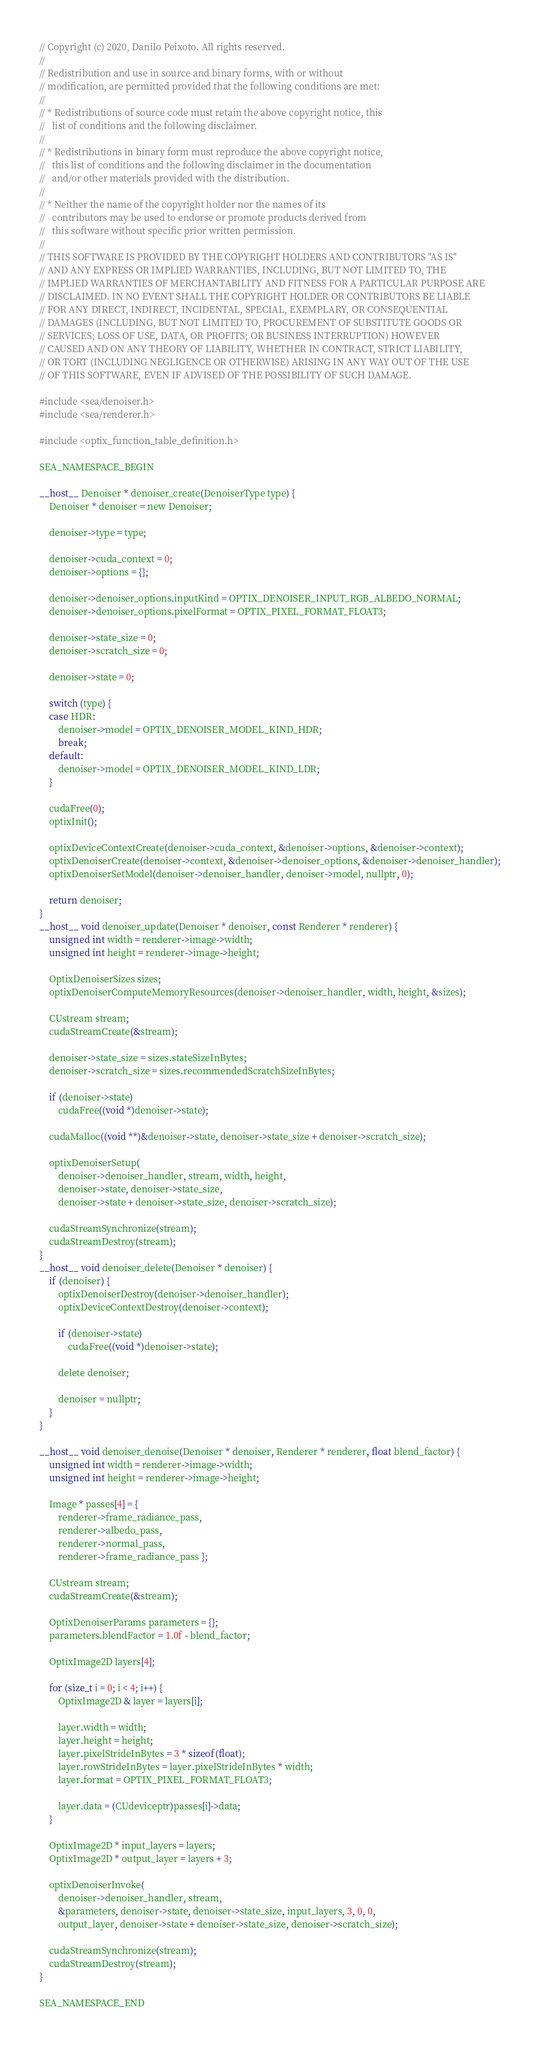Convert code to text. <code><loc_0><loc_0><loc_500><loc_500><_Cuda_>// Copyright (c) 2020, Danilo Peixoto. All rights reserved.
//
// Redistribution and use in source and binary forms, with or without
// modification, are permitted provided that the following conditions are met:
//
// * Redistributions of source code must retain the above copyright notice, this
//   list of conditions and the following disclaimer.
//
// * Redistributions in binary form must reproduce the above copyright notice,
//   this list of conditions and the following disclaimer in the documentation
//   and/or other materials provided with the distribution.
//
// * Neither the name of the copyright holder nor the names of its
//   contributors may be used to endorse or promote products derived from
//   this software without specific prior written permission.
//
// THIS SOFTWARE IS PROVIDED BY THE COPYRIGHT HOLDERS AND CONTRIBUTORS "AS IS"
// AND ANY EXPRESS OR IMPLIED WARRANTIES, INCLUDING, BUT NOT LIMITED TO, THE
// IMPLIED WARRANTIES OF MERCHANTABILITY AND FITNESS FOR A PARTICULAR PURPOSE ARE
// DISCLAIMED. IN NO EVENT SHALL THE COPYRIGHT HOLDER OR CONTRIBUTORS BE LIABLE
// FOR ANY DIRECT, INDIRECT, INCIDENTAL, SPECIAL, EXEMPLARY, OR CONSEQUENTIAL
// DAMAGES (INCLUDING, BUT NOT LIMITED TO, PROCUREMENT OF SUBSTITUTE GOODS OR
// SERVICES; LOSS OF USE, DATA, OR PROFITS; OR BUSINESS INTERRUPTION) HOWEVER
// CAUSED AND ON ANY THEORY OF LIABILITY, WHETHER IN CONTRACT, STRICT LIABILITY,
// OR TORT (INCLUDING NEGLIGENCE OR OTHERWISE) ARISING IN ANY WAY OUT OF THE USE
// OF THIS SOFTWARE, EVEN IF ADVISED OF THE POSSIBILITY OF SUCH DAMAGE.

#include <sea/denoiser.h>
#include <sea/renderer.h>

#include <optix_function_table_definition.h>

SEA_NAMESPACE_BEGIN

__host__ Denoiser * denoiser_create(DenoiserType type) {
	Denoiser * denoiser = new Denoiser;

	denoiser->type = type;

	denoiser->cuda_context = 0;
	denoiser->options = {};

	denoiser->denoiser_options.inputKind = OPTIX_DENOISER_INPUT_RGB_ALBEDO_NORMAL;
	denoiser->denoiser_options.pixelFormat = OPTIX_PIXEL_FORMAT_FLOAT3;

	denoiser->state_size = 0;
	denoiser->scratch_size = 0;

	denoiser->state = 0;

	switch (type) {
	case HDR:
		denoiser->model = OPTIX_DENOISER_MODEL_KIND_HDR;
		break;
	default:
		denoiser->model = OPTIX_DENOISER_MODEL_KIND_LDR;
	}

	cudaFree(0);
	optixInit();

	optixDeviceContextCreate(denoiser->cuda_context, &denoiser->options, &denoiser->context);
	optixDenoiserCreate(denoiser->context, &denoiser->denoiser_options, &denoiser->denoiser_handler);
	optixDenoiserSetModel(denoiser->denoiser_handler, denoiser->model, nullptr, 0);

	return denoiser;
}
__host__ void denoiser_update(Denoiser * denoiser, const Renderer * renderer) {
	unsigned int width = renderer->image->width;
	unsigned int height = renderer->image->height;

	OptixDenoiserSizes sizes;
	optixDenoiserComputeMemoryResources(denoiser->denoiser_handler, width, height, &sizes);

	CUstream stream;
	cudaStreamCreate(&stream);

	denoiser->state_size = sizes.stateSizeInBytes;
	denoiser->scratch_size = sizes.recommendedScratchSizeInBytes;

	if (denoiser->state)
		cudaFree((void *)denoiser->state);

	cudaMalloc((void **)&denoiser->state, denoiser->state_size + denoiser->scratch_size);

	optixDenoiserSetup(
		denoiser->denoiser_handler, stream, width, height,
		denoiser->state, denoiser->state_size,
		denoiser->state + denoiser->state_size, denoiser->scratch_size);

	cudaStreamSynchronize(stream);
	cudaStreamDestroy(stream);
}
__host__ void denoiser_delete(Denoiser * denoiser) {
	if (denoiser) {
		optixDenoiserDestroy(denoiser->denoiser_handler);
		optixDeviceContextDestroy(denoiser->context);

		if (denoiser->state)
			cudaFree((void *)denoiser->state);

		delete denoiser;

		denoiser = nullptr;
	}
}

__host__ void denoiser_denoise(Denoiser * denoiser, Renderer * renderer, float blend_factor) {
	unsigned int width = renderer->image->width;
	unsigned int height = renderer->image->height;

	Image * passes[4] = {
		renderer->frame_radiance_pass,
		renderer->albedo_pass,
		renderer->normal_pass,
		renderer->frame_radiance_pass };

	CUstream stream;
	cudaStreamCreate(&stream);

	OptixDenoiserParams parameters = {};
	parameters.blendFactor = 1.0f - blend_factor;

	OptixImage2D layers[4];

	for (size_t i = 0; i < 4; i++) {
		OptixImage2D & layer = layers[i];

		layer.width = width;
		layer.height = height;
		layer.pixelStrideInBytes = 3 * sizeof(float);
		layer.rowStrideInBytes = layer.pixelStrideInBytes * width;
		layer.format = OPTIX_PIXEL_FORMAT_FLOAT3;

		layer.data = (CUdeviceptr)passes[i]->data;
	}

	OptixImage2D * input_layers = layers;
	OptixImage2D * output_layer = layers + 3;

	optixDenoiserInvoke(
		denoiser->denoiser_handler, stream,
		&parameters, denoiser->state, denoiser->state_size, input_layers, 3, 0, 0,
		output_layer, denoiser->state + denoiser->state_size, denoiser->scratch_size);

	cudaStreamSynchronize(stream);
	cudaStreamDestroy(stream);
}

SEA_NAMESPACE_END</code> 